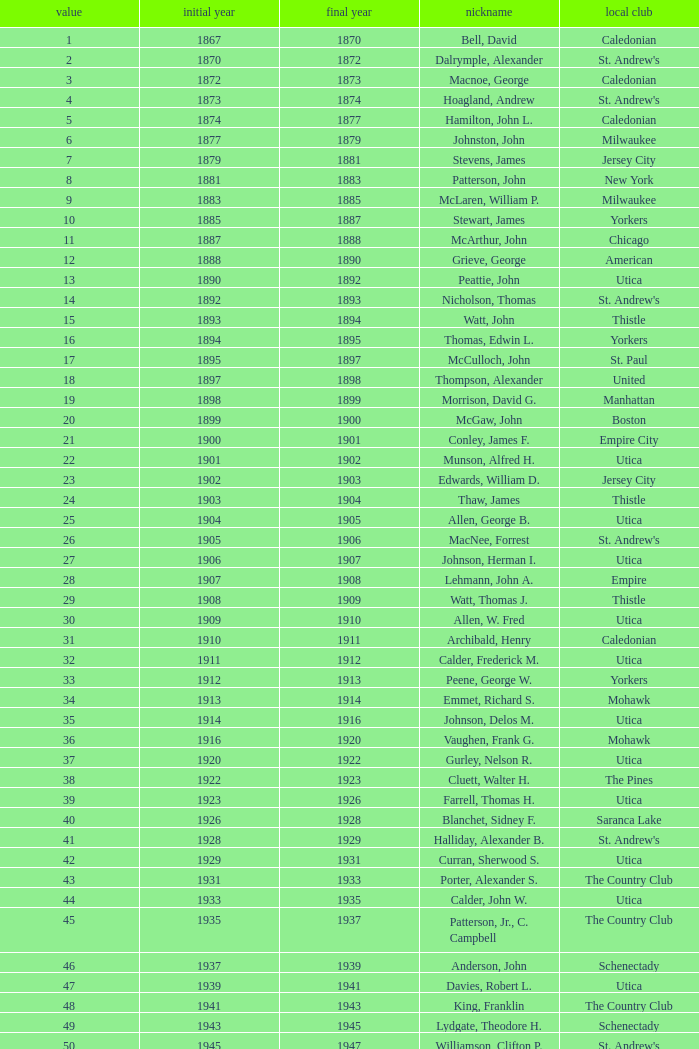Which Number has a Name of hill, lucius t.? 53.0. 